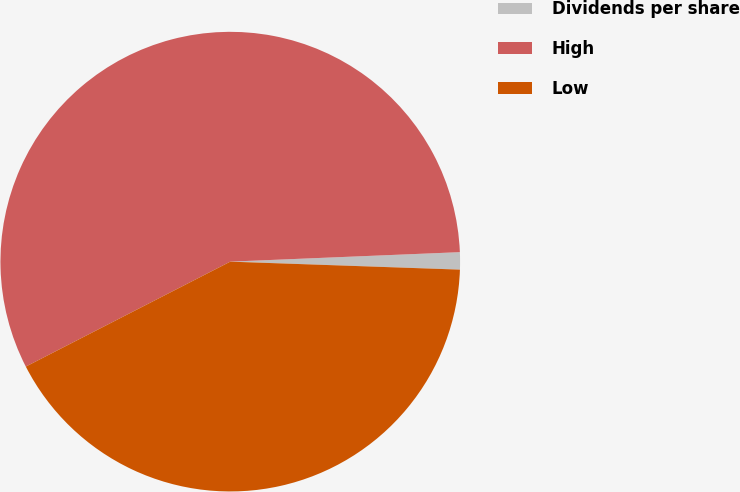<chart> <loc_0><loc_0><loc_500><loc_500><pie_chart><fcel>Dividends per share<fcel>High<fcel>Low<nl><fcel>1.21%<fcel>56.89%<fcel>41.9%<nl></chart> 